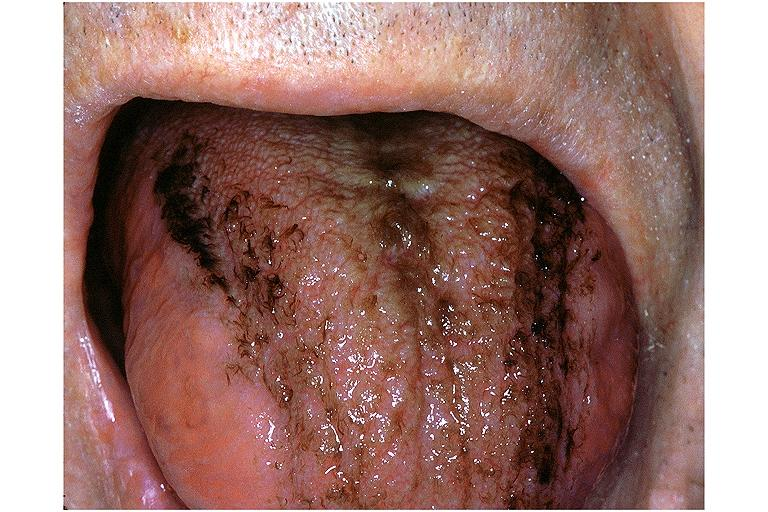where is this?
Answer the question using a single word or phrase. Oral 